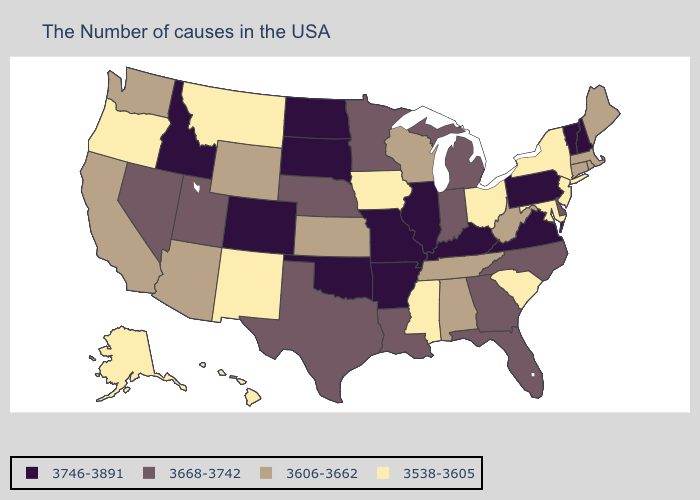Does Louisiana have a higher value than Alabama?
Be succinct. Yes. Does the first symbol in the legend represent the smallest category?
Give a very brief answer. No. Does New Hampshire have a higher value than Vermont?
Answer briefly. No. What is the lowest value in states that border South Dakota?
Be succinct. 3538-3605. Does Wyoming have the same value as Washington?
Short answer required. Yes. What is the value of Nebraska?
Answer briefly. 3668-3742. Does Pennsylvania have the highest value in the Northeast?
Short answer required. Yes. What is the value of South Dakota?
Keep it brief. 3746-3891. Name the states that have a value in the range 3746-3891?
Short answer required. New Hampshire, Vermont, Pennsylvania, Virginia, Kentucky, Illinois, Missouri, Arkansas, Oklahoma, South Dakota, North Dakota, Colorado, Idaho. Does Kentucky have the same value as Oregon?
Write a very short answer. No. Name the states that have a value in the range 3668-3742?
Give a very brief answer. Delaware, North Carolina, Florida, Georgia, Michigan, Indiana, Louisiana, Minnesota, Nebraska, Texas, Utah, Nevada. What is the value of Oklahoma?
Give a very brief answer. 3746-3891. What is the value of Kansas?
Quick response, please. 3606-3662. What is the highest value in the USA?
Be succinct. 3746-3891. 